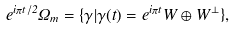Convert formula to latex. <formula><loc_0><loc_0><loc_500><loc_500>e ^ { i \pi t / 2 } \Omega _ { m } = \{ \gamma | \gamma ( t ) = e ^ { i \pi t } W \oplus W ^ { \perp } \} ,</formula> 